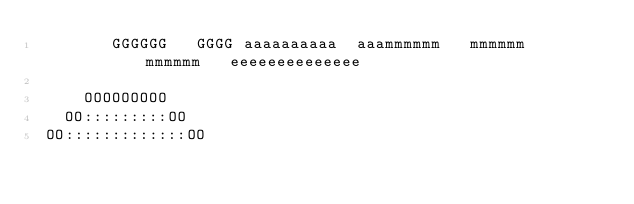Convert code to text. <code><loc_0><loc_0><loc_500><loc_500><_Python_>        GGGGGG   GGGG aaaaaaaaaa  aaammmmmm   mmmmmm   mmmmmm   eeeeeeeeeeeeee  
                                                                             
     OOOOOOOOO                                                                
   OO:::::::::OO                                                              
 OO:::::::::::::OO                                                            </code> 